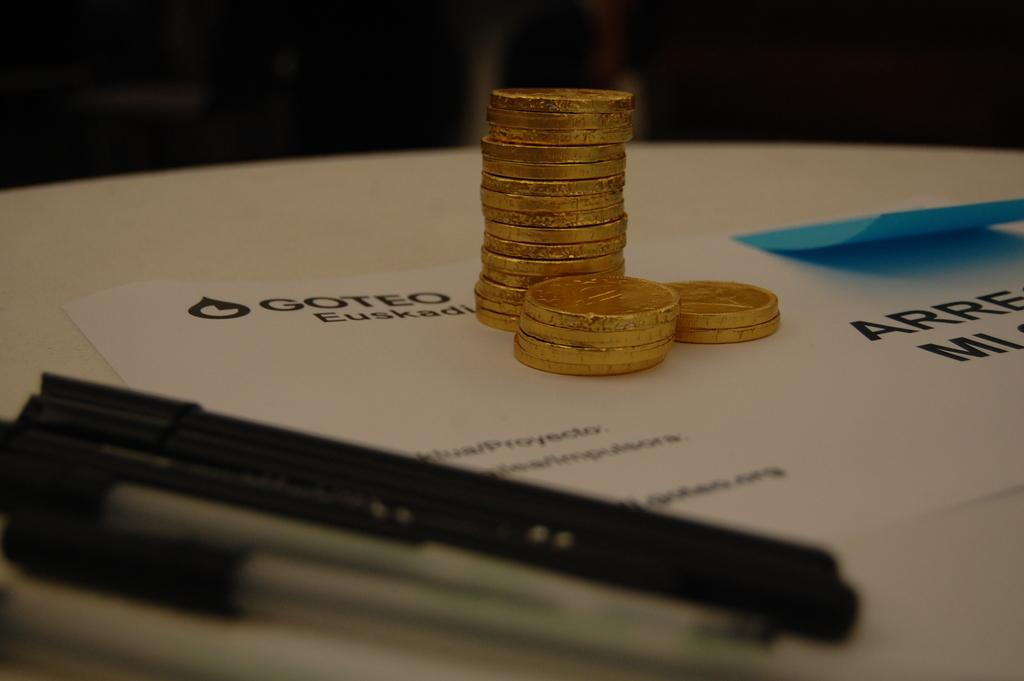<image>
Summarize the visual content of the image. The envelope has the business name Goteo on it 